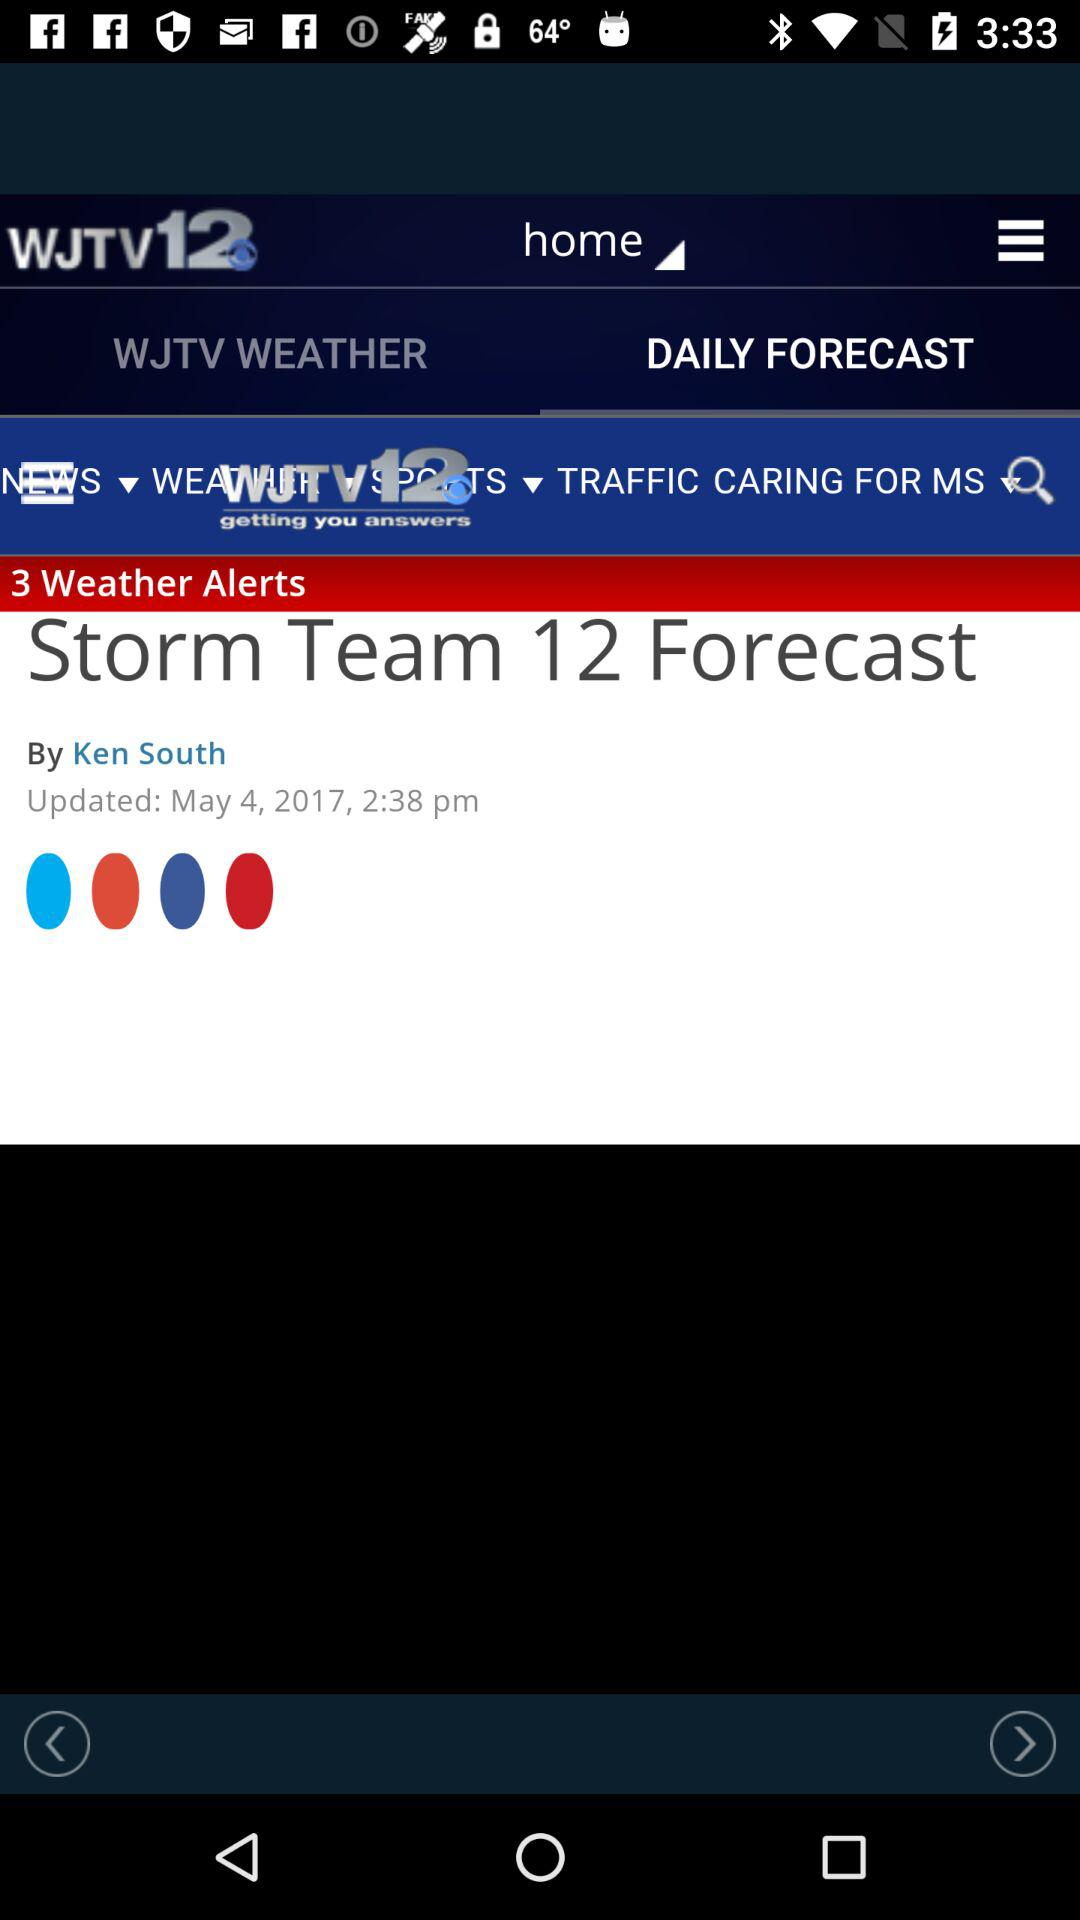How many weather alerts are mentioned? The mentioned weather alerts are 3. 